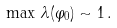Convert formula to latex. <formula><loc_0><loc_0><loc_500><loc_500>\max \, \lambda ( \varphi _ { 0 } ) \sim 1 \, .</formula> 